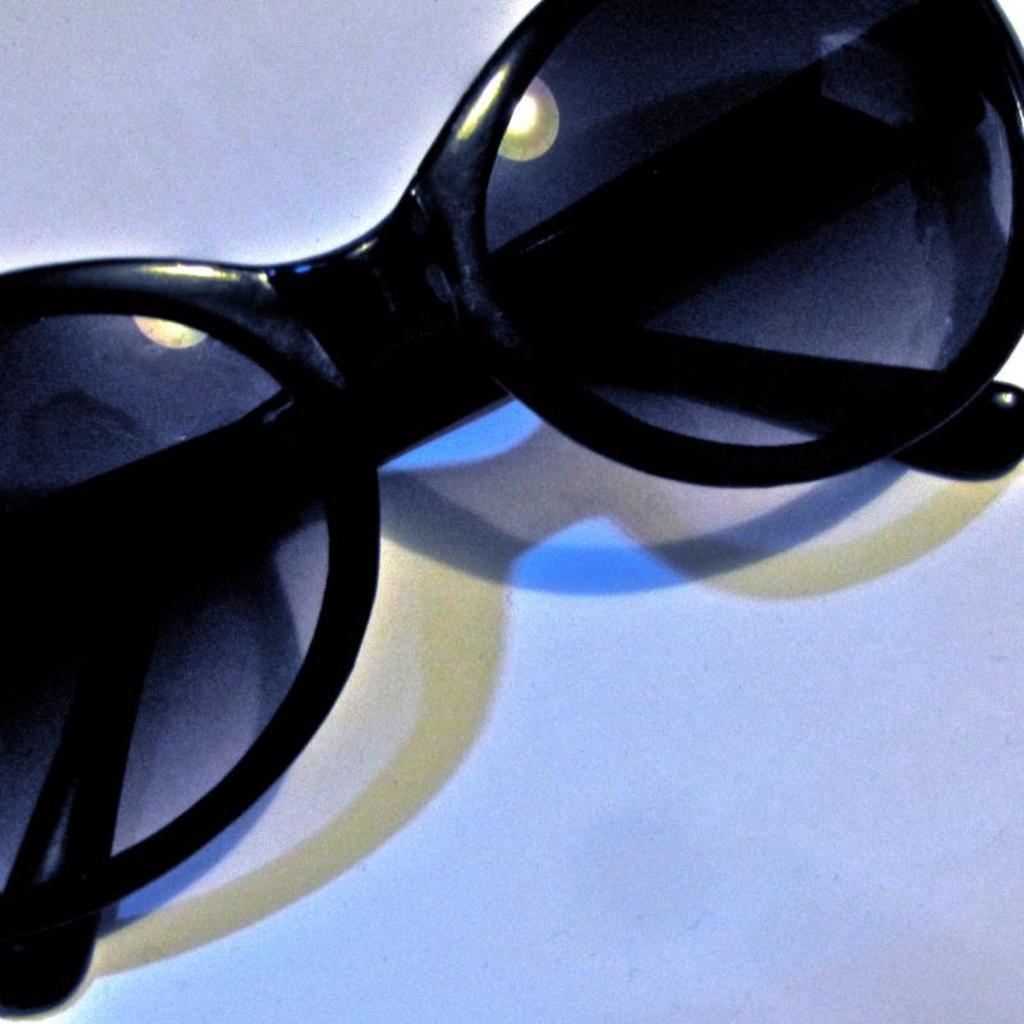In one or two sentences, can you explain what this image depicts? In this image there is a google on the white color surface. 